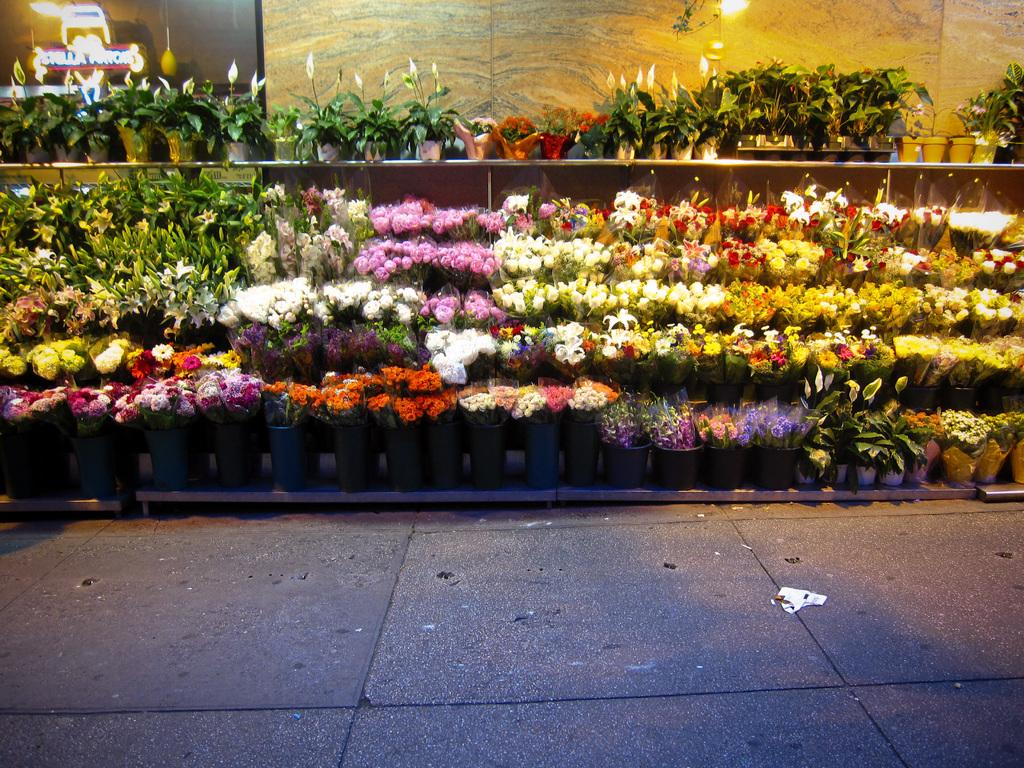What is in the foreground of the image? There is pavement in the foreground of the image. What can be seen in the center of the image? There are plants, bouquets, and flowers in the center of the image. What is present at the top of the image? There is a hoarding and a light at the top of the image. How many frogs can be seen hopping on the pavement in the image? There are no frogs present in the image; it features pavement, plants, bouquets, flowers, a hoarding, and a light. Is there a party happening in the image? There is no indication of a party in the image. 